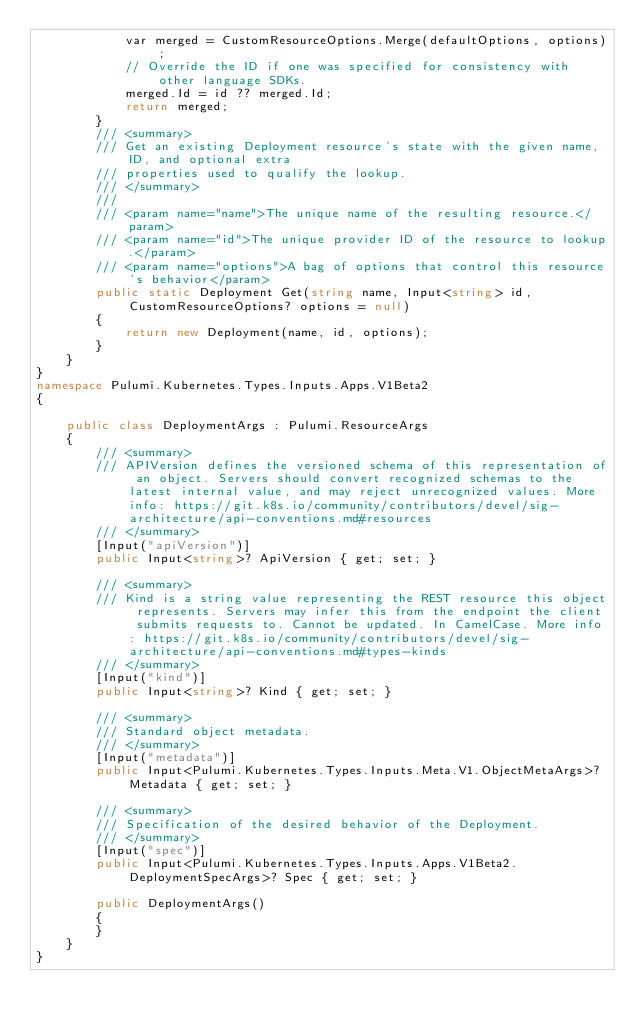Convert code to text. <code><loc_0><loc_0><loc_500><loc_500><_C#_>            var merged = CustomResourceOptions.Merge(defaultOptions, options);
            // Override the ID if one was specified for consistency with other language SDKs.
            merged.Id = id ?? merged.Id;
            return merged;
        }
        /// <summary>
        /// Get an existing Deployment resource's state with the given name, ID, and optional extra
        /// properties used to qualify the lookup.
        /// </summary>
        ///
        /// <param name="name">The unique name of the resulting resource.</param>
        /// <param name="id">The unique provider ID of the resource to lookup.</param>
        /// <param name="options">A bag of options that control this resource's behavior</param>
        public static Deployment Get(string name, Input<string> id, CustomResourceOptions? options = null)
        {
            return new Deployment(name, id, options);
        }
    }
}
namespace Pulumi.Kubernetes.Types.Inputs.Apps.V1Beta2
{

    public class DeploymentArgs : Pulumi.ResourceArgs
    {
        /// <summary>
        /// APIVersion defines the versioned schema of this representation of an object. Servers should convert recognized schemas to the latest internal value, and may reject unrecognized values. More info: https://git.k8s.io/community/contributors/devel/sig-architecture/api-conventions.md#resources
        /// </summary>
        [Input("apiVersion")]
        public Input<string>? ApiVersion { get; set; }

        /// <summary>
        /// Kind is a string value representing the REST resource this object represents. Servers may infer this from the endpoint the client submits requests to. Cannot be updated. In CamelCase. More info: https://git.k8s.io/community/contributors/devel/sig-architecture/api-conventions.md#types-kinds
        /// </summary>
        [Input("kind")]
        public Input<string>? Kind { get; set; }

        /// <summary>
        /// Standard object metadata.
        /// </summary>
        [Input("metadata")]
        public Input<Pulumi.Kubernetes.Types.Inputs.Meta.V1.ObjectMetaArgs>? Metadata { get; set; }

        /// <summary>
        /// Specification of the desired behavior of the Deployment.
        /// </summary>
        [Input("spec")]
        public Input<Pulumi.Kubernetes.Types.Inputs.Apps.V1Beta2.DeploymentSpecArgs>? Spec { get; set; }

        public DeploymentArgs()
        {
        }
    }
}
</code> 